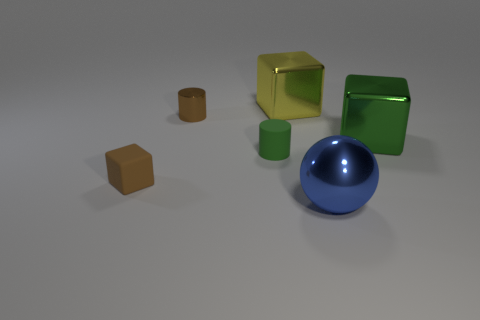Are there any green things that have the same material as the tiny cube?
Ensure brevity in your answer.  Yes. Are there the same number of brown matte cubes behind the matte cylinder and balls right of the big ball?
Make the answer very short. Yes. There is a cube that is left of the yellow thing; what size is it?
Give a very brief answer. Small. What material is the cube behind the metallic thing on the left side of the yellow block?
Provide a succinct answer. Metal. There is a green object in front of the large metallic object that is on the right side of the big blue metal ball; how many large things are to the left of it?
Your response must be concise. 0. Is the thing in front of the rubber block made of the same material as the green thing that is in front of the big green metal block?
Offer a very short reply. No. There is a small cube that is the same color as the metal cylinder; what is its material?
Offer a terse response. Rubber. How many other big objects are the same shape as the green shiny thing?
Offer a terse response. 1. Is the number of metal objects that are in front of the shiny cylinder greater than the number of cyan spheres?
Ensure brevity in your answer.  Yes. The small brown object that is behind the cylinder that is in front of the brown thing behind the small matte cylinder is what shape?
Your answer should be very brief. Cylinder. 